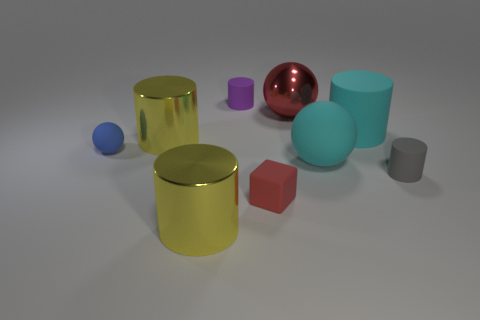Subtract all red cylinders. Subtract all purple spheres. How many cylinders are left? 5 Add 1 big green rubber things. How many objects exist? 10 Subtract all blocks. How many objects are left? 8 Add 8 cyan rubber spheres. How many cyan rubber spheres exist? 9 Subtract 0 blue cylinders. How many objects are left? 9 Subtract all cylinders. Subtract all cyan cubes. How many objects are left? 4 Add 2 small gray rubber cylinders. How many small gray rubber cylinders are left? 3 